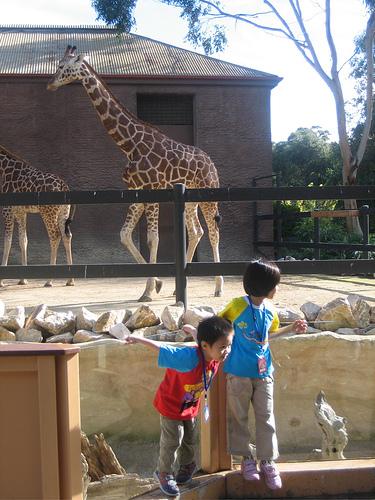How many kids are there?
Short answer required. 2. Are the giraffes eating?
Keep it brief. No. Are they looking at the giraffes?
Be succinct. No. 